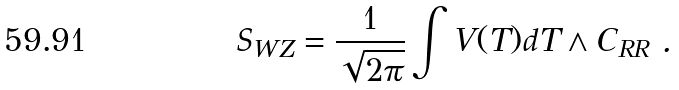Convert formula to latex. <formula><loc_0><loc_0><loc_500><loc_500>S _ { W Z } = \frac { 1 } { \sqrt { 2 \pi } } \int V ( T ) d T \wedge C _ { R R } \ .</formula> 